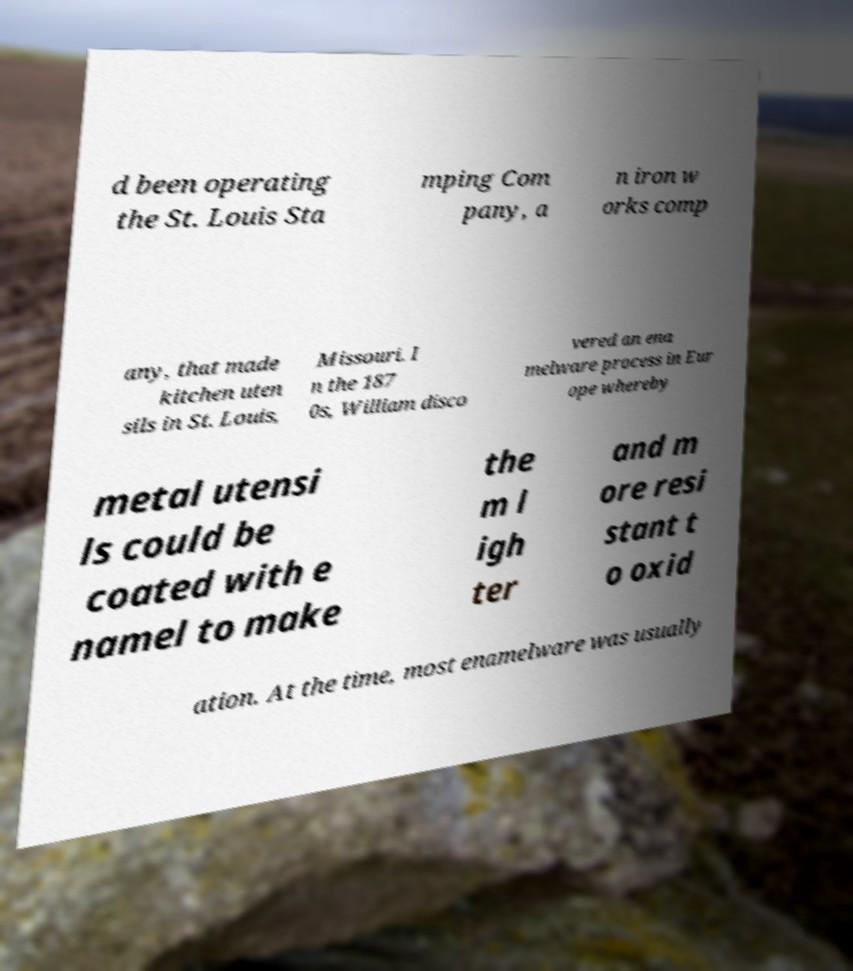Can you accurately transcribe the text from the provided image for me? d been operating the St. Louis Sta mping Com pany, a n iron w orks comp any, that made kitchen uten sils in St. Louis, Missouri. I n the 187 0s, William disco vered an ena melware process in Eur ope whereby metal utensi ls could be coated with e namel to make the m l igh ter and m ore resi stant t o oxid ation. At the time, most enamelware was usually 